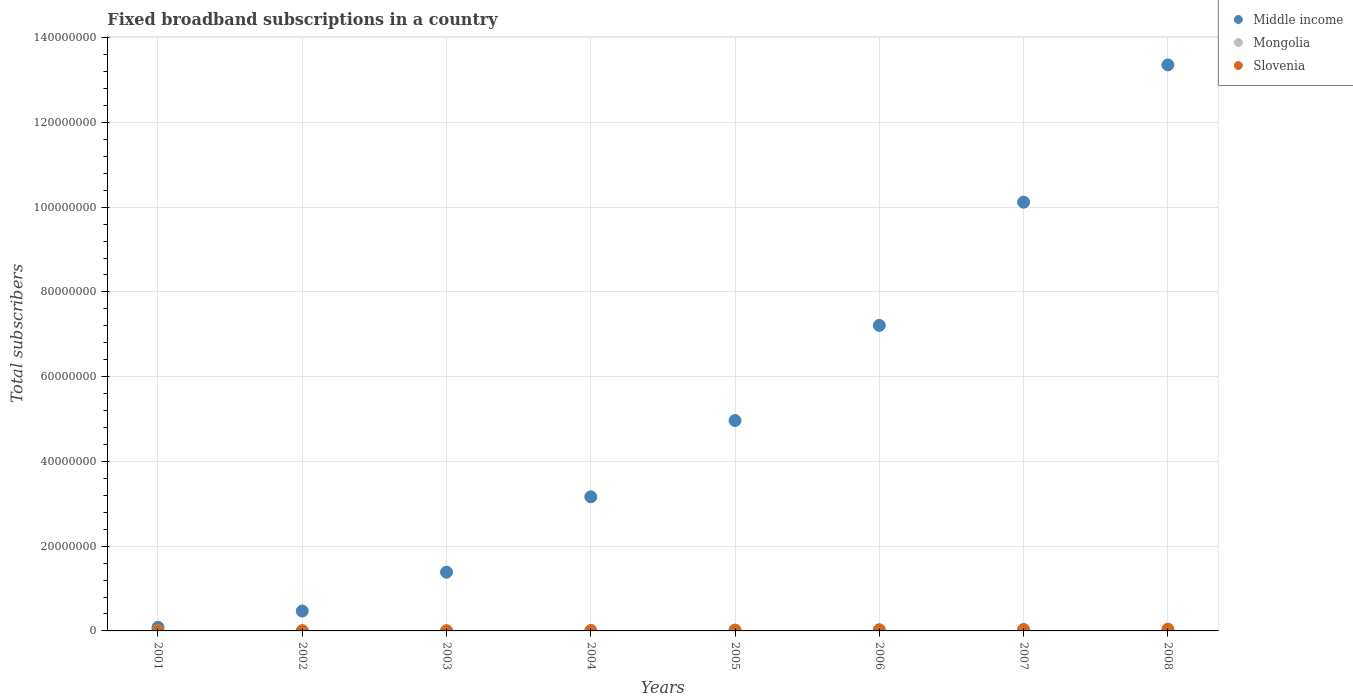How many different coloured dotlines are there?
Give a very brief answer. 3. Is the number of dotlines equal to the number of legend labels?
Make the answer very short. Yes. What is the number of broadband subscriptions in Mongolia in 2005?
Ensure brevity in your answer.  1800. Across all years, what is the maximum number of broadband subscriptions in Slovenia?
Offer a terse response. 4.25e+05. Across all years, what is the minimum number of broadband subscriptions in Slovenia?
Make the answer very short. 5500. In which year was the number of broadband subscriptions in Middle income minimum?
Provide a short and direct response. 2001. What is the total number of broadband subscriptions in Middle income in the graph?
Your answer should be very brief. 4.08e+08. What is the difference between the number of broadband subscriptions in Middle income in 2006 and that in 2007?
Make the answer very short. -2.91e+07. What is the difference between the number of broadband subscriptions in Slovenia in 2004 and the number of broadband subscriptions in Mongolia in 2003?
Ensure brevity in your answer.  1.15e+05. What is the average number of broadband subscriptions in Middle income per year?
Keep it short and to the point. 5.09e+07. In the year 2003, what is the difference between the number of broadband subscriptions in Slovenia and number of broadband subscriptions in Middle income?
Make the answer very short. -1.38e+07. What is the ratio of the number of broadband subscriptions in Slovenia in 2002 to that in 2006?
Offer a terse response. 0.2. What is the difference between the highest and the second highest number of broadband subscriptions in Slovenia?
Your answer should be compact. 8.06e+04. What is the difference between the highest and the lowest number of broadband subscriptions in Slovenia?
Offer a very short reply. 4.20e+05. In how many years, is the number of broadband subscriptions in Slovenia greater than the average number of broadband subscriptions in Slovenia taken over all years?
Your response must be concise. 4. Is the sum of the number of broadband subscriptions in Middle income in 2002 and 2008 greater than the maximum number of broadband subscriptions in Mongolia across all years?
Give a very brief answer. Yes. Does the number of broadband subscriptions in Middle income monotonically increase over the years?
Your answer should be compact. Yes. How many years are there in the graph?
Offer a terse response. 8. What is the difference between two consecutive major ticks on the Y-axis?
Make the answer very short. 2.00e+07. Are the values on the major ticks of Y-axis written in scientific E-notation?
Your answer should be compact. No. Does the graph contain any zero values?
Provide a short and direct response. No. How are the legend labels stacked?
Your answer should be compact. Vertical. What is the title of the graph?
Provide a succinct answer. Fixed broadband subscriptions in a country. What is the label or title of the X-axis?
Offer a very short reply. Years. What is the label or title of the Y-axis?
Ensure brevity in your answer.  Total subscribers. What is the Total subscribers in Middle income in 2001?
Your answer should be very brief. 8.47e+05. What is the Total subscribers in Slovenia in 2001?
Your response must be concise. 5500. What is the Total subscribers of Middle income in 2002?
Your answer should be very brief. 4.69e+06. What is the Total subscribers in Slovenia in 2002?
Your response must be concise. 5.67e+04. What is the Total subscribers of Middle income in 2003?
Your answer should be very brief. 1.39e+07. What is the Total subscribers of Mongolia in 2003?
Keep it short and to the point. 500. What is the Total subscribers of Slovenia in 2003?
Ensure brevity in your answer.  5.80e+04. What is the Total subscribers in Middle income in 2004?
Keep it short and to the point. 3.16e+07. What is the Total subscribers of Mongolia in 2004?
Your answer should be compact. 900. What is the Total subscribers in Slovenia in 2004?
Keep it short and to the point. 1.15e+05. What is the Total subscribers in Middle income in 2005?
Ensure brevity in your answer.  4.96e+07. What is the Total subscribers of Mongolia in 2005?
Provide a short and direct response. 1800. What is the Total subscribers in Slovenia in 2005?
Keep it short and to the point. 1.97e+05. What is the Total subscribers of Middle income in 2006?
Offer a very short reply. 7.21e+07. What is the Total subscribers in Mongolia in 2006?
Provide a succinct answer. 3500. What is the Total subscribers in Slovenia in 2006?
Ensure brevity in your answer.  2.80e+05. What is the Total subscribers of Middle income in 2007?
Provide a short and direct response. 1.01e+08. What is the Total subscribers in Mongolia in 2007?
Offer a very short reply. 7395. What is the Total subscribers in Slovenia in 2007?
Keep it short and to the point. 3.45e+05. What is the Total subscribers in Middle income in 2008?
Give a very brief answer. 1.34e+08. What is the Total subscribers in Mongolia in 2008?
Your answer should be very brief. 3.25e+04. What is the Total subscribers in Slovenia in 2008?
Your answer should be very brief. 4.25e+05. Across all years, what is the maximum Total subscribers in Middle income?
Provide a short and direct response. 1.34e+08. Across all years, what is the maximum Total subscribers in Mongolia?
Your answer should be compact. 3.25e+04. Across all years, what is the maximum Total subscribers in Slovenia?
Provide a succinct answer. 4.25e+05. Across all years, what is the minimum Total subscribers of Middle income?
Offer a very short reply. 8.47e+05. Across all years, what is the minimum Total subscribers in Mongolia?
Your answer should be very brief. 49. Across all years, what is the minimum Total subscribers of Slovenia?
Offer a very short reply. 5500. What is the total Total subscribers of Middle income in the graph?
Make the answer very short. 4.08e+08. What is the total Total subscribers in Mongolia in the graph?
Ensure brevity in your answer.  4.67e+04. What is the total Total subscribers in Slovenia in the graph?
Your response must be concise. 1.48e+06. What is the difference between the Total subscribers of Middle income in 2001 and that in 2002?
Keep it short and to the point. -3.85e+06. What is the difference between the Total subscribers in Mongolia in 2001 and that in 2002?
Give a very brief answer. -41. What is the difference between the Total subscribers in Slovenia in 2001 and that in 2002?
Keep it short and to the point. -5.12e+04. What is the difference between the Total subscribers of Middle income in 2001 and that in 2003?
Your response must be concise. -1.30e+07. What is the difference between the Total subscribers of Mongolia in 2001 and that in 2003?
Your answer should be very brief. -451. What is the difference between the Total subscribers in Slovenia in 2001 and that in 2003?
Your answer should be very brief. -5.25e+04. What is the difference between the Total subscribers of Middle income in 2001 and that in 2004?
Provide a succinct answer. -3.08e+07. What is the difference between the Total subscribers of Mongolia in 2001 and that in 2004?
Ensure brevity in your answer.  -851. What is the difference between the Total subscribers of Slovenia in 2001 and that in 2004?
Ensure brevity in your answer.  -1.10e+05. What is the difference between the Total subscribers of Middle income in 2001 and that in 2005?
Make the answer very short. -4.88e+07. What is the difference between the Total subscribers of Mongolia in 2001 and that in 2005?
Offer a terse response. -1751. What is the difference between the Total subscribers of Slovenia in 2001 and that in 2005?
Ensure brevity in your answer.  -1.91e+05. What is the difference between the Total subscribers in Middle income in 2001 and that in 2006?
Your response must be concise. -7.13e+07. What is the difference between the Total subscribers of Mongolia in 2001 and that in 2006?
Make the answer very short. -3451. What is the difference between the Total subscribers of Slovenia in 2001 and that in 2006?
Offer a very short reply. -2.74e+05. What is the difference between the Total subscribers of Middle income in 2001 and that in 2007?
Ensure brevity in your answer.  -1.00e+08. What is the difference between the Total subscribers of Mongolia in 2001 and that in 2007?
Offer a terse response. -7346. What is the difference between the Total subscribers of Slovenia in 2001 and that in 2007?
Ensure brevity in your answer.  -3.39e+05. What is the difference between the Total subscribers in Middle income in 2001 and that in 2008?
Your answer should be compact. -1.33e+08. What is the difference between the Total subscribers of Mongolia in 2001 and that in 2008?
Offer a very short reply. -3.25e+04. What is the difference between the Total subscribers of Slovenia in 2001 and that in 2008?
Offer a terse response. -4.20e+05. What is the difference between the Total subscribers in Middle income in 2002 and that in 2003?
Offer a terse response. -9.16e+06. What is the difference between the Total subscribers of Mongolia in 2002 and that in 2003?
Keep it short and to the point. -410. What is the difference between the Total subscribers of Slovenia in 2002 and that in 2003?
Give a very brief answer. -1257. What is the difference between the Total subscribers of Middle income in 2002 and that in 2004?
Provide a succinct answer. -2.70e+07. What is the difference between the Total subscribers in Mongolia in 2002 and that in 2004?
Your response must be concise. -810. What is the difference between the Total subscribers in Slovenia in 2002 and that in 2004?
Your answer should be compact. -5.83e+04. What is the difference between the Total subscribers in Middle income in 2002 and that in 2005?
Provide a succinct answer. -4.50e+07. What is the difference between the Total subscribers in Mongolia in 2002 and that in 2005?
Your answer should be very brief. -1710. What is the difference between the Total subscribers of Slovenia in 2002 and that in 2005?
Keep it short and to the point. -1.40e+05. What is the difference between the Total subscribers in Middle income in 2002 and that in 2006?
Your answer should be compact. -6.74e+07. What is the difference between the Total subscribers in Mongolia in 2002 and that in 2006?
Provide a short and direct response. -3410. What is the difference between the Total subscribers of Slovenia in 2002 and that in 2006?
Offer a very short reply. -2.23e+05. What is the difference between the Total subscribers of Middle income in 2002 and that in 2007?
Keep it short and to the point. -9.65e+07. What is the difference between the Total subscribers of Mongolia in 2002 and that in 2007?
Offer a very short reply. -7305. What is the difference between the Total subscribers of Slovenia in 2002 and that in 2007?
Your answer should be compact. -2.88e+05. What is the difference between the Total subscribers in Middle income in 2002 and that in 2008?
Ensure brevity in your answer.  -1.29e+08. What is the difference between the Total subscribers of Mongolia in 2002 and that in 2008?
Offer a very short reply. -3.24e+04. What is the difference between the Total subscribers in Slovenia in 2002 and that in 2008?
Your answer should be compact. -3.69e+05. What is the difference between the Total subscribers of Middle income in 2003 and that in 2004?
Provide a short and direct response. -1.78e+07. What is the difference between the Total subscribers of Mongolia in 2003 and that in 2004?
Keep it short and to the point. -400. What is the difference between the Total subscribers of Slovenia in 2003 and that in 2004?
Provide a short and direct response. -5.71e+04. What is the difference between the Total subscribers of Middle income in 2003 and that in 2005?
Provide a succinct answer. -3.58e+07. What is the difference between the Total subscribers of Mongolia in 2003 and that in 2005?
Make the answer very short. -1300. What is the difference between the Total subscribers of Slovenia in 2003 and that in 2005?
Offer a very short reply. -1.39e+05. What is the difference between the Total subscribers in Middle income in 2003 and that in 2006?
Ensure brevity in your answer.  -5.82e+07. What is the difference between the Total subscribers of Mongolia in 2003 and that in 2006?
Ensure brevity in your answer.  -3000. What is the difference between the Total subscribers of Slovenia in 2003 and that in 2006?
Your response must be concise. -2.22e+05. What is the difference between the Total subscribers of Middle income in 2003 and that in 2007?
Provide a short and direct response. -8.73e+07. What is the difference between the Total subscribers in Mongolia in 2003 and that in 2007?
Keep it short and to the point. -6895. What is the difference between the Total subscribers of Slovenia in 2003 and that in 2007?
Ensure brevity in your answer.  -2.87e+05. What is the difference between the Total subscribers in Middle income in 2003 and that in 2008?
Keep it short and to the point. -1.20e+08. What is the difference between the Total subscribers of Mongolia in 2003 and that in 2008?
Provide a short and direct response. -3.20e+04. What is the difference between the Total subscribers in Slovenia in 2003 and that in 2008?
Keep it short and to the point. -3.67e+05. What is the difference between the Total subscribers in Middle income in 2004 and that in 2005?
Ensure brevity in your answer.  -1.80e+07. What is the difference between the Total subscribers in Mongolia in 2004 and that in 2005?
Provide a succinct answer. -900. What is the difference between the Total subscribers of Slovenia in 2004 and that in 2005?
Your response must be concise. -8.16e+04. What is the difference between the Total subscribers of Middle income in 2004 and that in 2006?
Offer a very short reply. -4.05e+07. What is the difference between the Total subscribers in Mongolia in 2004 and that in 2006?
Give a very brief answer. -2600. What is the difference between the Total subscribers of Slovenia in 2004 and that in 2006?
Your response must be concise. -1.65e+05. What is the difference between the Total subscribers of Middle income in 2004 and that in 2007?
Provide a short and direct response. -6.95e+07. What is the difference between the Total subscribers of Mongolia in 2004 and that in 2007?
Keep it short and to the point. -6495. What is the difference between the Total subscribers of Slovenia in 2004 and that in 2007?
Your answer should be very brief. -2.30e+05. What is the difference between the Total subscribers of Middle income in 2004 and that in 2008?
Your answer should be compact. -1.02e+08. What is the difference between the Total subscribers of Mongolia in 2004 and that in 2008?
Your answer should be very brief. -3.16e+04. What is the difference between the Total subscribers of Slovenia in 2004 and that in 2008?
Offer a very short reply. -3.10e+05. What is the difference between the Total subscribers of Middle income in 2005 and that in 2006?
Ensure brevity in your answer.  -2.25e+07. What is the difference between the Total subscribers in Mongolia in 2005 and that in 2006?
Make the answer very short. -1700. What is the difference between the Total subscribers in Slovenia in 2005 and that in 2006?
Give a very brief answer. -8.32e+04. What is the difference between the Total subscribers in Middle income in 2005 and that in 2007?
Offer a very short reply. -5.15e+07. What is the difference between the Total subscribers in Mongolia in 2005 and that in 2007?
Offer a very short reply. -5595. What is the difference between the Total subscribers in Slovenia in 2005 and that in 2007?
Give a very brief answer. -1.48e+05. What is the difference between the Total subscribers in Middle income in 2005 and that in 2008?
Provide a succinct answer. -8.39e+07. What is the difference between the Total subscribers in Mongolia in 2005 and that in 2008?
Offer a very short reply. -3.07e+04. What is the difference between the Total subscribers in Slovenia in 2005 and that in 2008?
Give a very brief answer. -2.29e+05. What is the difference between the Total subscribers of Middle income in 2006 and that in 2007?
Provide a short and direct response. -2.91e+07. What is the difference between the Total subscribers in Mongolia in 2006 and that in 2007?
Make the answer very short. -3895. What is the difference between the Total subscribers of Slovenia in 2006 and that in 2007?
Give a very brief answer. -6.49e+04. What is the difference between the Total subscribers of Middle income in 2006 and that in 2008?
Keep it short and to the point. -6.15e+07. What is the difference between the Total subscribers of Mongolia in 2006 and that in 2008?
Give a very brief answer. -2.90e+04. What is the difference between the Total subscribers in Slovenia in 2006 and that in 2008?
Make the answer very short. -1.45e+05. What is the difference between the Total subscribers of Middle income in 2007 and that in 2008?
Make the answer very short. -3.24e+07. What is the difference between the Total subscribers of Mongolia in 2007 and that in 2008?
Provide a short and direct response. -2.51e+04. What is the difference between the Total subscribers of Slovenia in 2007 and that in 2008?
Your answer should be compact. -8.06e+04. What is the difference between the Total subscribers in Middle income in 2001 and the Total subscribers in Mongolia in 2002?
Your answer should be very brief. 8.47e+05. What is the difference between the Total subscribers of Middle income in 2001 and the Total subscribers of Slovenia in 2002?
Your response must be concise. 7.90e+05. What is the difference between the Total subscribers of Mongolia in 2001 and the Total subscribers of Slovenia in 2002?
Provide a short and direct response. -5.67e+04. What is the difference between the Total subscribers in Middle income in 2001 and the Total subscribers in Mongolia in 2003?
Give a very brief answer. 8.46e+05. What is the difference between the Total subscribers in Middle income in 2001 and the Total subscribers in Slovenia in 2003?
Your answer should be compact. 7.89e+05. What is the difference between the Total subscribers in Mongolia in 2001 and the Total subscribers in Slovenia in 2003?
Offer a terse response. -5.79e+04. What is the difference between the Total subscribers in Middle income in 2001 and the Total subscribers in Mongolia in 2004?
Your answer should be compact. 8.46e+05. What is the difference between the Total subscribers of Middle income in 2001 and the Total subscribers of Slovenia in 2004?
Keep it short and to the point. 7.32e+05. What is the difference between the Total subscribers in Mongolia in 2001 and the Total subscribers in Slovenia in 2004?
Your response must be concise. -1.15e+05. What is the difference between the Total subscribers of Middle income in 2001 and the Total subscribers of Mongolia in 2005?
Your response must be concise. 8.45e+05. What is the difference between the Total subscribers in Middle income in 2001 and the Total subscribers in Slovenia in 2005?
Your answer should be compact. 6.50e+05. What is the difference between the Total subscribers of Mongolia in 2001 and the Total subscribers of Slovenia in 2005?
Ensure brevity in your answer.  -1.97e+05. What is the difference between the Total subscribers in Middle income in 2001 and the Total subscribers in Mongolia in 2006?
Keep it short and to the point. 8.43e+05. What is the difference between the Total subscribers of Middle income in 2001 and the Total subscribers of Slovenia in 2006?
Offer a very short reply. 5.67e+05. What is the difference between the Total subscribers in Mongolia in 2001 and the Total subscribers in Slovenia in 2006?
Keep it short and to the point. -2.80e+05. What is the difference between the Total subscribers in Middle income in 2001 and the Total subscribers in Mongolia in 2007?
Ensure brevity in your answer.  8.39e+05. What is the difference between the Total subscribers in Middle income in 2001 and the Total subscribers in Slovenia in 2007?
Keep it short and to the point. 5.02e+05. What is the difference between the Total subscribers of Mongolia in 2001 and the Total subscribers of Slovenia in 2007?
Your response must be concise. -3.45e+05. What is the difference between the Total subscribers in Middle income in 2001 and the Total subscribers in Mongolia in 2008?
Offer a very short reply. 8.14e+05. What is the difference between the Total subscribers of Middle income in 2001 and the Total subscribers of Slovenia in 2008?
Your answer should be very brief. 4.21e+05. What is the difference between the Total subscribers of Mongolia in 2001 and the Total subscribers of Slovenia in 2008?
Keep it short and to the point. -4.25e+05. What is the difference between the Total subscribers of Middle income in 2002 and the Total subscribers of Mongolia in 2003?
Provide a succinct answer. 4.69e+06. What is the difference between the Total subscribers in Middle income in 2002 and the Total subscribers in Slovenia in 2003?
Your answer should be very brief. 4.64e+06. What is the difference between the Total subscribers of Mongolia in 2002 and the Total subscribers of Slovenia in 2003?
Your answer should be very brief. -5.79e+04. What is the difference between the Total subscribers of Middle income in 2002 and the Total subscribers of Mongolia in 2004?
Provide a succinct answer. 4.69e+06. What is the difference between the Total subscribers in Middle income in 2002 and the Total subscribers in Slovenia in 2004?
Provide a short and direct response. 4.58e+06. What is the difference between the Total subscribers of Mongolia in 2002 and the Total subscribers of Slovenia in 2004?
Keep it short and to the point. -1.15e+05. What is the difference between the Total subscribers in Middle income in 2002 and the Total subscribers in Mongolia in 2005?
Your response must be concise. 4.69e+06. What is the difference between the Total subscribers of Middle income in 2002 and the Total subscribers of Slovenia in 2005?
Offer a terse response. 4.50e+06. What is the difference between the Total subscribers in Mongolia in 2002 and the Total subscribers in Slovenia in 2005?
Your answer should be compact. -1.97e+05. What is the difference between the Total subscribers in Middle income in 2002 and the Total subscribers in Mongolia in 2006?
Ensure brevity in your answer.  4.69e+06. What is the difference between the Total subscribers in Middle income in 2002 and the Total subscribers in Slovenia in 2006?
Keep it short and to the point. 4.41e+06. What is the difference between the Total subscribers in Mongolia in 2002 and the Total subscribers in Slovenia in 2006?
Offer a terse response. -2.80e+05. What is the difference between the Total subscribers in Middle income in 2002 and the Total subscribers in Mongolia in 2007?
Your response must be concise. 4.69e+06. What is the difference between the Total subscribers in Middle income in 2002 and the Total subscribers in Slovenia in 2007?
Offer a terse response. 4.35e+06. What is the difference between the Total subscribers in Mongolia in 2002 and the Total subscribers in Slovenia in 2007?
Offer a terse response. -3.45e+05. What is the difference between the Total subscribers in Middle income in 2002 and the Total subscribers in Mongolia in 2008?
Provide a short and direct response. 4.66e+06. What is the difference between the Total subscribers of Middle income in 2002 and the Total subscribers of Slovenia in 2008?
Your answer should be very brief. 4.27e+06. What is the difference between the Total subscribers of Mongolia in 2002 and the Total subscribers of Slovenia in 2008?
Provide a short and direct response. -4.25e+05. What is the difference between the Total subscribers in Middle income in 2003 and the Total subscribers in Mongolia in 2004?
Offer a very short reply. 1.39e+07. What is the difference between the Total subscribers of Middle income in 2003 and the Total subscribers of Slovenia in 2004?
Offer a very short reply. 1.37e+07. What is the difference between the Total subscribers of Mongolia in 2003 and the Total subscribers of Slovenia in 2004?
Make the answer very short. -1.15e+05. What is the difference between the Total subscribers in Middle income in 2003 and the Total subscribers in Mongolia in 2005?
Give a very brief answer. 1.39e+07. What is the difference between the Total subscribers of Middle income in 2003 and the Total subscribers of Slovenia in 2005?
Ensure brevity in your answer.  1.37e+07. What is the difference between the Total subscribers of Mongolia in 2003 and the Total subscribers of Slovenia in 2005?
Ensure brevity in your answer.  -1.96e+05. What is the difference between the Total subscribers of Middle income in 2003 and the Total subscribers of Mongolia in 2006?
Give a very brief answer. 1.39e+07. What is the difference between the Total subscribers in Middle income in 2003 and the Total subscribers in Slovenia in 2006?
Offer a very short reply. 1.36e+07. What is the difference between the Total subscribers of Mongolia in 2003 and the Total subscribers of Slovenia in 2006?
Make the answer very short. -2.79e+05. What is the difference between the Total subscribers of Middle income in 2003 and the Total subscribers of Mongolia in 2007?
Your response must be concise. 1.39e+07. What is the difference between the Total subscribers in Middle income in 2003 and the Total subscribers in Slovenia in 2007?
Give a very brief answer. 1.35e+07. What is the difference between the Total subscribers of Mongolia in 2003 and the Total subscribers of Slovenia in 2007?
Ensure brevity in your answer.  -3.44e+05. What is the difference between the Total subscribers of Middle income in 2003 and the Total subscribers of Mongolia in 2008?
Your answer should be compact. 1.38e+07. What is the difference between the Total subscribers in Middle income in 2003 and the Total subscribers in Slovenia in 2008?
Ensure brevity in your answer.  1.34e+07. What is the difference between the Total subscribers in Mongolia in 2003 and the Total subscribers in Slovenia in 2008?
Provide a succinct answer. -4.25e+05. What is the difference between the Total subscribers in Middle income in 2004 and the Total subscribers in Mongolia in 2005?
Give a very brief answer. 3.16e+07. What is the difference between the Total subscribers in Middle income in 2004 and the Total subscribers in Slovenia in 2005?
Keep it short and to the point. 3.15e+07. What is the difference between the Total subscribers in Mongolia in 2004 and the Total subscribers in Slovenia in 2005?
Your answer should be compact. -1.96e+05. What is the difference between the Total subscribers in Middle income in 2004 and the Total subscribers in Mongolia in 2006?
Your response must be concise. 3.16e+07. What is the difference between the Total subscribers of Middle income in 2004 and the Total subscribers of Slovenia in 2006?
Keep it short and to the point. 3.14e+07. What is the difference between the Total subscribers of Mongolia in 2004 and the Total subscribers of Slovenia in 2006?
Provide a succinct answer. -2.79e+05. What is the difference between the Total subscribers in Middle income in 2004 and the Total subscribers in Mongolia in 2007?
Ensure brevity in your answer.  3.16e+07. What is the difference between the Total subscribers of Middle income in 2004 and the Total subscribers of Slovenia in 2007?
Your answer should be compact. 3.13e+07. What is the difference between the Total subscribers of Mongolia in 2004 and the Total subscribers of Slovenia in 2007?
Make the answer very short. -3.44e+05. What is the difference between the Total subscribers in Middle income in 2004 and the Total subscribers in Mongolia in 2008?
Ensure brevity in your answer.  3.16e+07. What is the difference between the Total subscribers of Middle income in 2004 and the Total subscribers of Slovenia in 2008?
Give a very brief answer. 3.12e+07. What is the difference between the Total subscribers of Mongolia in 2004 and the Total subscribers of Slovenia in 2008?
Your answer should be compact. -4.24e+05. What is the difference between the Total subscribers of Middle income in 2005 and the Total subscribers of Mongolia in 2006?
Offer a very short reply. 4.96e+07. What is the difference between the Total subscribers of Middle income in 2005 and the Total subscribers of Slovenia in 2006?
Ensure brevity in your answer.  4.94e+07. What is the difference between the Total subscribers in Mongolia in 2005 and the Total subscribers in Slovenia in 2006?
Offer a very short reply. -2.78e+05. What is the difference between the Total subscribers in Middle income in 2005 and the Total subscribers in Mongolia in 2007?
Provide a succinct answer. 4.96e+07. What is the difference between the Total subscribers of Middle income in 2005 and the Total subscribers of Slovenia in 2007?
Give a very brief answer. 4.93e+07. What is the difference between the Total subscribers of Mongolia in 2005 and the Total subscribers of Slovenia in 2007?
Your answer should be compact. -3.43e+05. What is the difference between the Total subscribers of Middle income in 2005 and the Total subscribers of Mongolia in 2008?
Give a very brief answer. 4.96e+07. What is the difference between the Total subscribers in Middle income in 2005 and the Total subscribers in Slovenia in 2008?
Provide a succinct answer. 4.92e+07. What is the difference between the Total subscribers of Mongolia in 2005 and the Total subscribers of Slovenia in 2008?
Offer a terse response. -4.23e+05. What is the difference between the Total subscribers of Middle income in 2006 and the Total subscribers of Mongolia in 2007?
Keep it short and to the point. 7.21e+07. What is the difference between the Total subscribers in Middle income in 2006 and the Total subscribers in Slovenia in 2007?
Provide a short and direct response. 7.18e+07. What is the difference between the Total subscribers of Mongolia in 2006 and the Total subscribers of Slovenia in 2007?
Your answer should be compact. -3.41e+05. What is the difference between the Total subscribers in Middle income in 2006 and the Total subscribers in Mongolia in 2008?
Ensure brevity in your answer.  7.21e+07. What is the difference between the Total subscribers in Middle income in 2006 and the Total subscribers in Slovenia in 2008?
Make the answer very short. 7.17e+07. What is the difference between the Total subscribers of Mongolia in 2006 and the Total subscribers of Slovenia in 2008?
Offer a very short reply. -4.22e+05. What is the difference between the Total subscribers of Middle income in 2007 and the Total subscribers of Mongolia in 2008?
Give a very brief answer. 1.01e+08. What is the difference between the Total subscribers of Middle income in 2007 and the Total subscribers of Slovenia in 2008?
Keep it short and to the point. 1.01e+08. What is the difference between the Total subscribers of Mongolia in 2007 and the Total subscribers of Slovenia in 2008?
Provide a short and direct response. -4.18e+05. What is the average Total subscribers in Middle income per year?
Provide a succinct answer. 5.09e+07. What is the average Total subscribers of Mongolia per year?
Make the answer very short. 5842.25. What is the average Total subscribers in Slovenia per year?
Ensure brevity in your answer.  1.85e+05. In the year 2001, what is the difference between the Total subscribers in Middle income and Total subscribers in Mongolia?
Provide a succinct answer. 8.47e+05. In the year 2001, what is the difference between the Total subscribers of Middle income and Total subscribers of Slovenia?
Your answer should be very brief. 8.41e+05. In the year 2001, what is the difference between the Total subscribers of Mongolia and Total subscribers of Slovenia?
Your response must be concise. -5451. In the year 2002, what is the difference between the Total subscribers in Middle income and Total subscribers in Mongolia?
Offer a very short reply. 4.69e+06. In the year 2002, what is the difference between the Total subscribers in Middle income and Total subscribers in Slovenia?
Offer a very short reply. 4.64e+06. In the year 2002, what is the difference between the Total subscribers in Mongolia and Total subscribers in Slovenia?
Give a very brief answer. -5.66e+04. In the year 2003, what is the difference between the Total subscribers of Middle income and Total subscribers of Mongolia?
Offer a terse response. 1.39e+07. In the year 2003, what is the difference between the Total subscribers of Middle income and Total subscribers of Slovenia?
Your answer should be very brief. 1.38e+07. In the year 2003, what is the difference between the Total subscribers in Mongolia and Total subscribers in Slovenia?
Your answer should be compact. -5.75e+04. In the year 2004, what is the difference between the Total subscribers in Middle income and Total subscribers in Mongolia?
Keep it short and to the point. 3.16e+07. In the year 2004, what is the difference between the Total subscribers of Middle income and Total subscribers of Slovenia?
Your answer should be compact. 3.15e+07. In the year 2004, what is the difference between the Total subscribers of Mongolia and Total subscribers of Slovenia?
Provide a succinct answer. -1.14e+05. In the year 2005, what is the difference between the Total subscribers of Middle income and Total subscribers of Mongolia?
Make the answer very short. 4.96e+07. In the year 2005, what is the difference between the Total subscribers of Middle income and Total subscribers of Slovenia?
Your answer should be very brief. 4.95e+07. In the year 2005, what is the difference between the Total subscribers of Mongolia and Total subscribers of Slovenia?
Offer a very short reply. -1.95e+05. In the year 2006, what is the difference between the Total subscribers in Middle income and Total subscribers in Mongolia?
Your answer should be compact. 7.21e+07. In the year 2006, what is the difference between the Total subscribers of Middle income and Total subscribers of Slovenia?
Your answer should be compact. 7.18e+07. In the year 2006, what is the difference between the Total subscribers in Mongolia and Total subscribers in Slovenia?
Provide a short and direct response. -2.76e+05. In the year 2007, what is the difference between the Total subscribers in Middle income and Total subscribers in Mongolia?
Your answer should be compact. 1.01e+08. In the year 2007, what is the difference between the Total subscribers in Middle income and Total subscribers in Slovenia?
Keep it short and to the point. 1.01e+08. In the year 2007, what is the difference between the Total subscribers of Mongolia and Total subscribers of Slovenia?
Make the answer very short. -3.37e+05. In the year 2008, what is the difference between the Total subscribers in Middle income and Total subscribers in Mongolia?
Keep it short and to the point. 1.34e+08. In the year 2008, what is the difference between the Total subscribers in Middle income and Total subscribers in Slovenia?
Give a very brief answer. 1.33e+08. In the year 2008, what is the difference between the Total subscribers of Mongolia and Total subscribers of Slovenia?
Offer a very short reply. -3.93e+05. What is the ratio of the Total subscribers in Middle income in 2001 to that in 2002?
Ensure brevity in your answer.  0.18. What is the ratio of the Total subscribers in Mongolia in 2001 to that in 2002?
Make the answer very short. 0.54. What is the ratio of the Total subscribers in Slovenia in 2001 to that in 2002?
Offer a very short reply. 0.1. What is the ratio of the Total subscribers in Middle income in 2001 to that in 2003?
Your answer should be very brief. 0.06. What is the ratio of the Total subscribers in Mongolia in 2001 to that in 2003?
Offer a very short reply. 0.1. What is the ratio of the Total subscribers of Slovenia in 2001 to that in 2003?
Keep it short and to the point. 0.09. What is the ratio of the Total subscribers of Middle income in 2001 to that in 2004?
Provide a succinct answer. 0.03. What is the ratio of the Total subscribers in Mongolia in 2001 to that in 2004?
Your answer should be compact. 0.05. What is the ratio of the Total subscribers of Slovenia in 2001 to that in 2004?
Provide a succinct answer. 0.05. What is the ratio of the Total subscribers of Middle income in 2001 to that in 2005?
Your answer should be compact. 0.02. What is the ratio of the Total subscribers of Mongolia in 2001 to that in 2005?
Ensure brevity in your answer.  0.03. What is the ratio of the Total subscribers in Slovenia in 2001 to that in 2005?
Ensure brevity in your answer.  0.03. What is the ratio of the Total subscribers in Middle income in 2001 to that in 2006?
Offer a terse response. 0.01. What is the ratio of the Total subscribers of Mongolia in 2001 to that in 2006?
Give a very brief answer. 0.01. What is the ratio of the Total subscribers in Slovenia in 2001 to that in 2006?
Keep it short and to the point. 0.02. What is the ratio of the Total subscribers in Middle income in 2001 to that in 2007?
Ensure brevity in your answer.  0.01. What is the ratio of the Total subscribers in Mongolia in 2001 to that in 2007?
Offer a very short reply. 0.01. What is the ratio of the Total subscribers of Slovenia in 2001 to that in 2007?
Make the answer very short. 0.02. What is the ratio of the Total subscribers in Middle income in 2001 to that in 2008?
Your answer should be very brief. 0.01. What is the ratio of the Total subscribers of Mongolia in 2001 to that in 2008?
Provide a succinct answer. 0. What is the ratio of the Total subscribers of Slovenia in 2001 to that in 2008?
Provide a succinct answer. 0.01. What is the ratio of the Total subscribers in Middle income in 2002 to that in 2003?
Keep it short and to the point. 0.34. What is the ratio of the Total subscribers in Mongolia in 2002 to that in 2003?
Provide a short and direct response. 0.18. What is the ratio of the Total subscribers of Slovenia in 2002 to that in 2003?
Keep it short and to the point. 0.98. What is the ratio of the Total subscribers of Middle income in 2002 to that in 2004?
Provide a short and direct response. 0.15. What is the ratio of the Total subscribers in Mongolia in 2002 to that in 2004?
Make the answer very short. 0.1. What is the ratio of the Total subscribers in Slovenia in 2002 to that in 2004?
Provide a short and direct response. 0.49. What is the ratio of the Total subscribers of Middle income in 2002 to that in 2005?
Give a very brief answer. 0.09. What is the ratio of the Total subscribers in Slovenia in 2002 to that in 2005?
Offer a terse response. 0.29. What is the ratio of the Total subscribers of Middle income in 2002 to that in 2006?
Make the answer very short. 0.07. What is the ratio of the Total subscribers of Mongolia in 2002 to that in 2006?
Your answer should be compact. 0.03. What is the ratio of the Total subscribers in Slovenia in 2002 to that in 2006?
Your response must be concise. 0.2. What is the ratio of the Total subscribers in Middle income in 2002 to that in 2007?
Provide a short and direct response. 0.05. What is the ratio of the Total subscribers in Mongolia in 2002 to that in 2007?
Make the answer very short. 0.01. What is the ratio of the Total subscribers of Slovenia in 2002 to that in 2007?
Your answer should be very brief. 0.16. What is the ratio of the Total subscribers of Middle income in 2002 to that in 2008?
Your answer should be compact. 0.04. What is the ratio of the Total subscribers of Mongolia in 2002 to that in 2008?
Make the answer very short. 0. What is the ratio of the Total subscribers in Slovenia in 2002 to that in 2008?
Your response must be concise. 0.13. What is the ratio of the Total subscribers in Middle income in 2003 to that in 2004?
Your answer should be compact. 0.44. What is the ratio of the Total subscribers in Mongolia in 2003 to that in 2004?
Offer a very short reply. 0.56. What is the ratio of the Total subscribers in Slovenia in 2003 to that in 2004?
Make the answer very short. 0.5. What is the ratio of the Total subscribers in Middle income in 2003 to that in 2005?
Give a very brief answer. 0.28. What is the ratio of the Total subscribers in Mongolia in 2003 to that in 2005?
Your answer should be compact. 0.28. What is the ratio of the Total subscribers of Slovenia in 2003 to that in 2005?
Your answer should be very brief. 0.29. What is the ratio of the Total subscribers in Middle income in 2003 to that in 2006?
Your answer should be very brief. 0.19. What is the ratio of the Total subscribers of Mongolia in 2003 to that in 2006?
Ensure brevity in your answer.  0.14. What is the ratio of the Total subscribers of Slovenia in 2003 to that in 2006?
Ensure brevity in your answer.  0.21. What is the ratio of the Total subscribers in Middle income in 2003 to that in 2007?
Provide a short and direct response. 0.14. What is the ratio of the Total subscribers in Mongolia in 2003 to that in 2007?
Your response must be concise. 0.07. What is the ratio of the Total subscribers in Slovenia in 2003 to that in 2007?
Your answer should be compact. 0.17. What is the ratio of the Total subscribers in Middle income in 2003 to that in 2008?
Your answer should be compact. 0.1. What is the ratio of the Total subscribers in Mongolia in 2003 to that in 2008?
Give a very brief answer. 0.02. What is the ratio of the Total subscribers in Slovenia in 2003 to that in 2008?
Offer a very short reply. 0.14. What is the ratio of the Total subscribers in Middle income in 2004 to that in 2005?
Give a very brief answer. 0.64. What is the ratio of the Total subscribers of Slovenia in 2004 to that in 2005?
Your answer should be very brief. 0.59. What is the ratio of the Total subscribers of Middle income in 2004 to that in 2006?
Your answer should be very brief. 0.44. What is the ratio of the Total subscribers in Mongolia in 2004 to that in 2006?
Offer a terse response. 0.26. What is the ratio of the Total subscribers of Slovenia in 2004 to that in 2006?
Your answer should be compact. 0.41. What is the ratio of the Total subscribers of Middle income in 2004 to that in 2007?
Give a very brief answer. 0.31. What is the ratio of the Total subscribers of Mongolia in 2004 to that in 2007?
Provide a short and direct response. 0.12. What is the ratio of the Total subscribers in Slovenia in 2004 to that in 2007?
Provide a succinct answer. 0.33. What is the ratio of the Total subscribers in Middle income in 2004 to that in 2008?
Give a very brief answer. 0.24. What is the ratio of the Total subscribers of Mongolia in 2004 to that in 2008?
Offer a very short reply. 0.03. What is the ratio of the Total subscribers in Slovenia in 2004 to that in 2008?
Give a very brief answer. 0.27. What is the ratio of the Total subscribers of Middle income in 2005 to that in 2006?
Ensure brevity in your answer.  0.69. What is the ratio of the Total subscribers in Mongolia in 2005 to that in 2006?
Keep it short and to the point. 0.51. What is the ratio of the Total subscribers of Slovenia in 2005 to that in 2006?
Ensure brevity in your answer.  0.7. What is the ratio of the Total subscribers in Middle income in 2005 to that in 2007?
Offer a very short reply. 0.49. What is the ratio of the Total subscribers in Mongolia in 2005 to that in 2007?
Provide a short and direct response. 0.24. What is the ratio of the Total subscribers in Slovenia in 2005 to that in 2007?
Your response must be concise. 0.57. What is the ratio of the Total subscribers of Middle income in 2005 to that in 2008?
Provide a succinct answer. 0.37. What is the ratio of the Total subscribers in Mongolia in 2005 to that in 2008?
Provide a short and direct response. 0.06. What is the ratio of the Total subscribers of Slovenia in 2005 to that in 2008?
Your answer should be very brief. 0.46. What is the ratio of the Total subscribers of Middle income in 2006 to that in 2007?
Provide a succinct answer. 0.71. What is the ratio of the Total subscribers of Mongolia in 2006 to that in 2007?
Keep it short and to the point. 0.47. What is the ratio of the Total subscribers in Slovenia in 2006 to that in 2007?
Provide a short and direct response. 0.81. What is the ratio of the Total subscribers in Middle income in 2006 to that in 2008?
Make the answer very short. 0.54. What is the ratio of the Total subscribers of Mongolia in 2006 to that in 2008?
Offer a terse response. 0.11. What is the ratio of the Total subscribers in Slovenia in 2006 to that in 2008?
Offer a very short reply. 0.66. What is the ratio of the Total subscribers in Middle income in 2007 to that in 2008?
Provide a short and direct response. 0.76. What is the ratio of the Total subscribers of Mongolia in 2007 to that in 2008?
Offer a terse response. 0.23. What is the ratio of the Total subscribers of Slovenia in 2007 to that in 2008?
Give a very brief answer. 0.81. What is the difference between the highest and the second highest Total subscribers in Middle income?
Give a very brief answer. 3.24e+07. What is the difference between the highest and the second highest Total subscribers of Mongolia?
Provide a succinct answer. 2.51e+04. What is the difference between the highest and the second highest Total subscribers of Slovenia?
Make the answer very short. 8.06e+04. What is the difference between the highest and the lowest Total subscribers of Middle income?
Offer a terse response. 1.33e+08. What is the difference between the highest and the lowest Total subscribers in Mongolia?
Your response must be concise. 3.25e+04. What is the difference between the highest and the lowest Total subscribers of Slovenia?
Ensure brevity in your answer.  4.20e+05. 